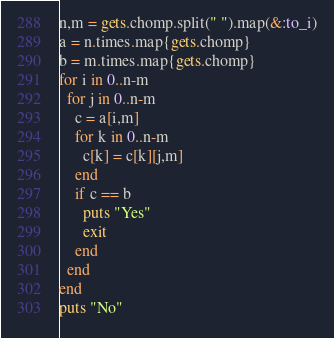<code> <loc_0><loc_0><loc_500><loc_500><_Ruby_>n,m = gets.chomp.split(" ").map(&:to_i)
a = n.times.map{gets.chomp}
b = m.times.map{gets.chomp}
for i in 0..n-m
  for j in 0..n-m
    c = a[i,m]
    for k in 0..n-m
      c[k] = c[k][j,m]
    end
    if c == b
      puts "Yes"
      exit
    end
  end
end
puts "No"</code> 